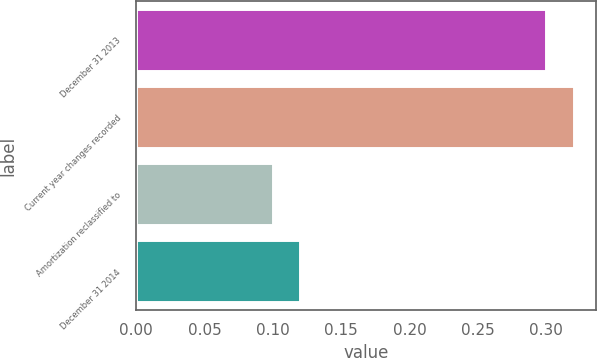Convert chart to OTSL. <chart><loc_0><loc_0><loc_500><loc_500><bar_chart><fcel>December 31 2013<fcel>Current year changes recorded<fcel>Amortization reclassified to<fcel>December 31 2014<nl><fcel>0.3<fcel>0.32<fcel>0.1<fcel>0.12<nl></chart> 